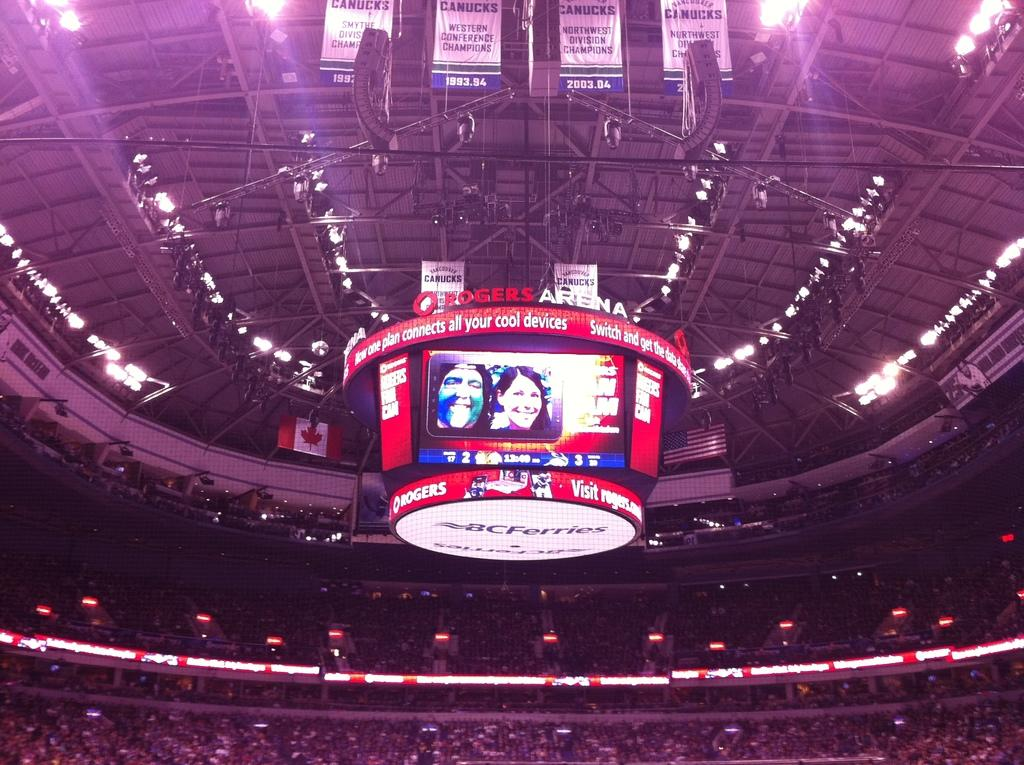What is the main subject of the image? The main subject of the image is a crowd. What can be seen in the background of the image? In the background, there is a fence, lights, boards, a screen, hoardings, metal rods, and a rooftop. Are there any posters present in the image? Yes, posters are present in the image. Can you see any rabbits hopping around in the image? No, there are no rabbits present in the image. What type of lace can be seen on the clothing of the people in the crowd? There is no mention of lace or clothing in the image, so it cannot be determined from the provided facts. 